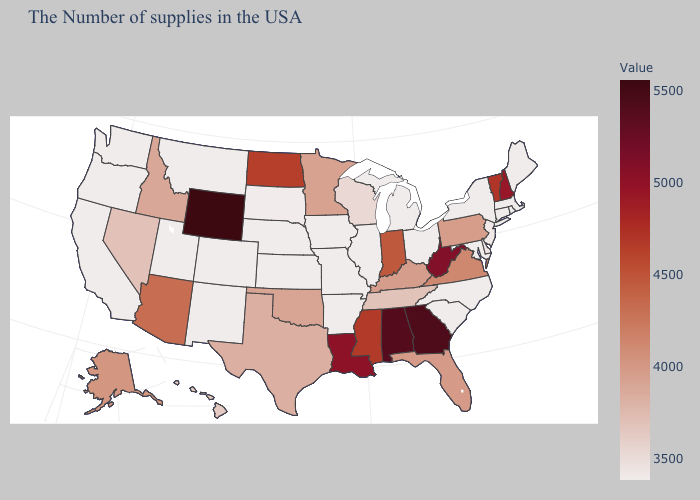Which states have the lowest value in the West?
Keep it brief. Colorado, New Mexico, Utah, Montana, California, Washington, Oregon. Among the states that border New York , which have the lowest value?
Keep it brief. Massachusetts, Connecticut. Among the states that border South Dakota , does Wyoming have the lowest value?
Keep it brief. No. Is the legend a continuous bar?
Keep it brief. Yes. Does Wyoming have the highest value in the USA?
Quick response, please. Yes. 